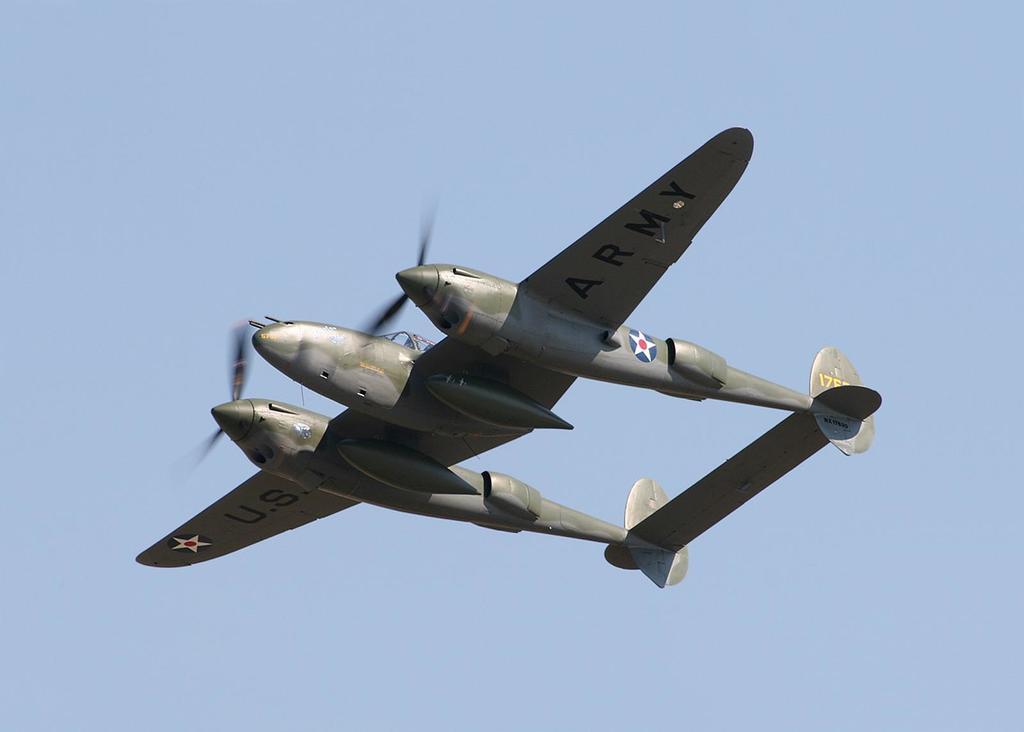Describe this image in one or two sentences. In this image we can see green color aircraft which is flying in the sky, which is of green color and at the background of the image there is clear sky. 